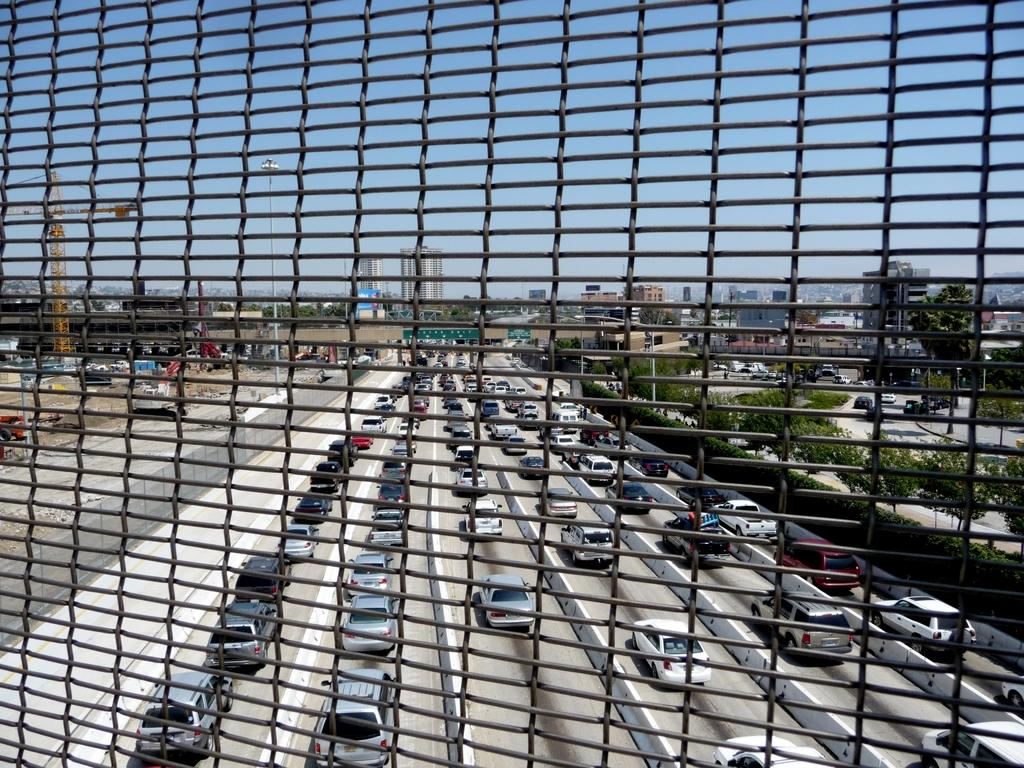What is the primary object in the image? There is a mesh in the image. What can be seen through the mesh? Vehicles on the road are visible through the mesh. What type of structures are present in the image? There are buildings in the image. What type of vegetation is present in the image? Trees and plants are visible in the image. What type of construction equipment is present in the image? A crane is present in the image. What is visible in the background of the image? The sky is visible in the image. What type of oatmeal is being served to the girl in the image? There is no girl or oatmeal present in the image. What type of machine is being used to construct the buildings in the image? The provided facts do not mention any specific machines used for construction; only a crane is mentioned. 